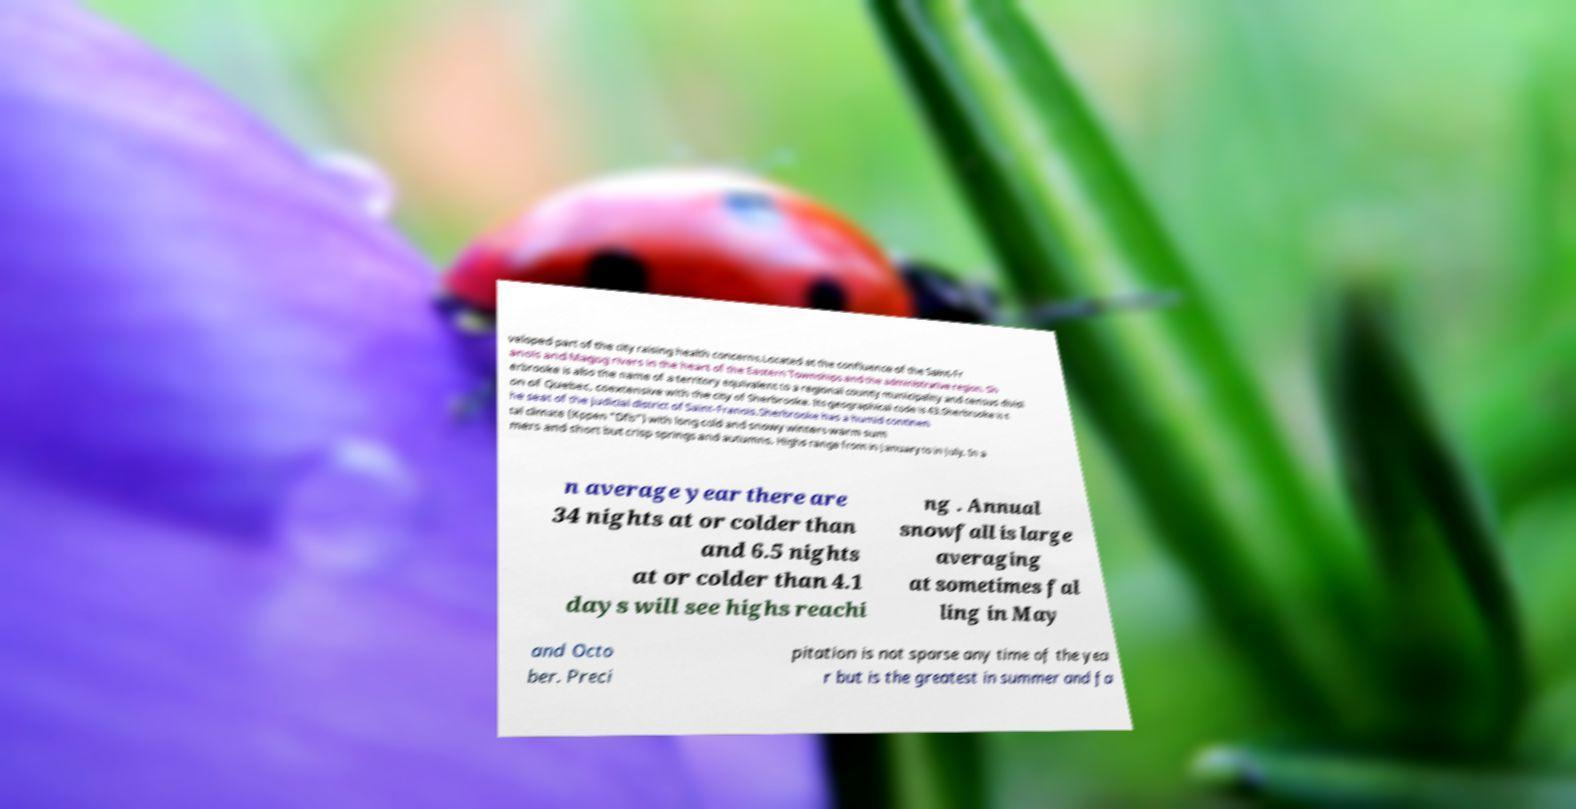What messages or text are displayed in this image? I need them in a readable, typed format. veloped part of the city raising health concerns.Located at the confluence of the Saint-Fr anois and Magog rivers in the heart of the Eastern Townships and the administrative region. Sh erbrooke is also the name of a territory equivalent to a regional county municipality and census divisi on of Quebec, coextensive with the city of Sherbrooke. Its geographical code is 43.Sherbrooke is t he seat of the judicial district of Saint-Franois.Sherbrooke has a humid continen tal climate (Kppen "Dfb") with long cold and snowy winters warm sum mers and short but crisp springs and autumns. Highs range from in January to in July. In a n average year there are 34 nights at or colder than and 6.5 nights at or colder than 4.1 days will see highs reachi ng . Annual snowfall is large averaging at sometimes fal ling in May and Octo ber. Preci pitation is not sparse any time of the yea r but is the greatest in summer and fa 